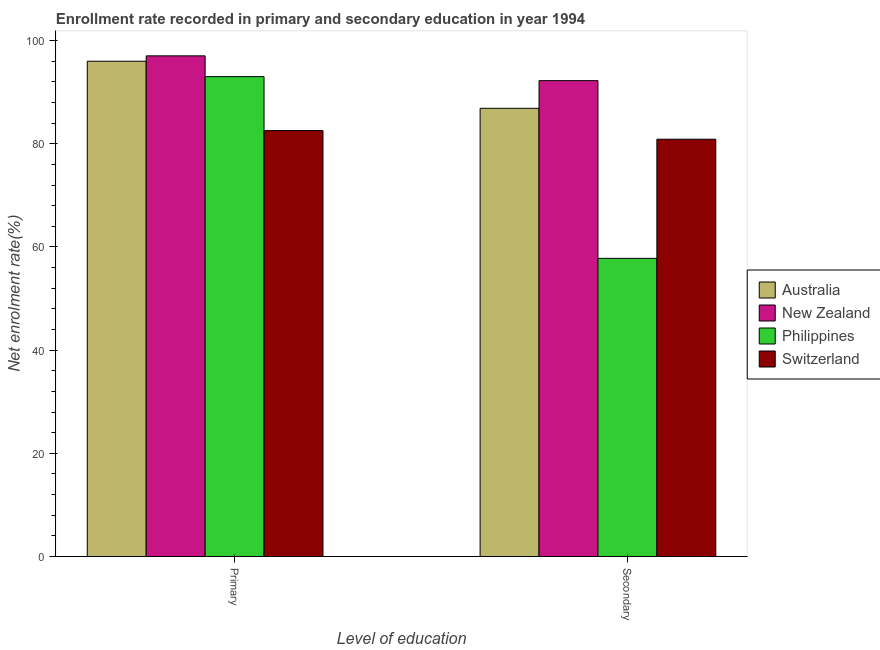How many groups of bars are there?
Provide a succinct answer. 2. Are the number of bars per tick equal to the number of legend labels?
Keep it short and to the point. Yes. Are the number of bars on each tick of the X-axis equal?
Your answer should be compact. Yes. How many bars are there on the 1st tick from the left?
Offer a terse response. 4. What is the label of the 2nd group of bars from the left?
Your answer should be compact. Secondary. What is the enrollment rate in primary education in Switzerland?
Your answer should be compact. 82.55. Across all countries, what is the maximum enrollment rate in secondary education?
Provide a succinct answer. 92.23. Across all countries, what is the minimum enrollment rate in secondary education?
Make the answer very short. 57.79. In which country was the enrollment rate in secondary education maximum?
Provide a short and direct response. New Zealand. In which country was the enrollment rate in secondary education minimum?
Your answer should be compact. Philippines. What is the total enrollment rate in secondary education in the graph?
Offer a terse response. 317.78. What is the difference between the enrollment rate in secondary education in Australia and that in New Zealand?
Provide a succinct answer. -5.36. What is the difference between the enrollment rate in primary education in New Zealand and the enrollment rate in secondary education in Switzerland?
Offer a terse response. 16.15. What is the average enrollment rate in primary education per country?
Provide a succinct answer. 92.15. What is the difference between the enrollment rate in secondary education and enrollment rate in primary education in Switzerland?
Make the answer very short. -1.67. In how many countries, is the enrollment rate in primary education greater than 4 %?
Make the answer very short. 4. What is the ratio of the enrollment rate in primary education in New Zealand to that in Australia?
Offer a very short reply. 1.01. Is the enrollment rate in secondary education in Philippines less than that in Switzerland?
Keep it short and to the point. Yes. In how many countries, is the enrollment rate in primary education greater than the average enrollment rate in primary education taken over all countries?
Ensure brevity in your answer.  3. What does the 2nd bar from the left in Primary represents?
Provide a short and direct response. New Zealand. What does the 3rd bar from the right in Secondary represents?
Your answer should be very brief. New Zealand. Are all the bars in the graph horizontal?
Ensure brevity in your answer.  No. What is the difference between two consecutive major ticks on the Y-axis?
Offer a terse response. 20. Does the graph contain any zero values?
Provide a short and direct response. No. Where does the legend appear in the graph?
Offer a terse response. Center right. How many legend labels are there?
Provide a succinct answer. 4. How are the legend labels stacked?
Give a very brief answer. Vertical. What is the title of the graph?
Provide a short and direct response. Enrollment rate recorded in primary and secondary education in year 1994. Does "Philippines" appear as one of the legend labels in the graph?
Your answer should be very brief. Yes. What is the label or title of the X-axis?
Provide a succinct answer. Level of education. What is the label or title of the Y-axis?
Keep it short and to the point. Net enrolment rate(%). What is the Net enrolment rate(%) of Australia in Primary?
Keep it short and to the point. 96. What is the Net enrolment rate(%) of New Zealand in Primary?
Offer a terse response. 97.04. What is the Net enrolment rate(%) of Philippines in Primary?
Provide a short and direct response. 93.01. What is the Net enrolment rate(%) in Switzerland in Primary?
Your answer should be compact. 82.55. What is the Net enrolment rate(%) in Australia in Secondary?
Make the answer very short. 86.87. What is the Net enrolment rate(%) in New Zealand in Secondary?
Your answer should be very brief. 92.23. What is the Net enrolment rate(%) in Philippines in Secondary?
Ensure brevity in your answer.  57.79. What is the Net enrolment rate(%) in Switzerland in Secondary?
Keep it short and to the point. 80.88. Across all Level of education, what is the maximum Net enrolment rate(%) of Australia?
Give a very brief answer. 96. Across all Level of education, what is the maximum Net enrolment rate(%) of New Zealand?
Your answer should be compact. 97.04. Across all Level of education, what is the maximum Net enrolment rate(%) of Philippines?
Your answer should be very brief. 93.01. Across all Level of education, what is the maximum Net enrolment rate(%) of Switzerland?
Offer a terse response. 82.55. Across all Level of education, what is the minimum Net enrolment rate(%) in Australia?
Provide a succinct answer. 86.87. Across all Level of education, what is the minimum Net enrolment rate(%) of New Zealand?
Offer a very short reply. 92.23. Across all Level of education, what is the minimum Net enrolment rate(%) of Philippines?
Keep it short and to the point. 57.79. Across all Level of education, what is the minimum Net enrolment rate(%) in Switzerland?
Keep it short and to the point. 80.88. What is the total Net enrolment rate(%) of Australia in the graph?
Keep it short and to the point. 182.87. What is the total Net enrolment rate(%) in New Zealand in the graph?
Provide a succinct answer. 189.27. What is the total Net enrolment rate(%) in Philippines in the graph?
Your answer should be compact. 150.8. What is the total Net enrolment rate(%) in Switzerland in the graph?
Give a very brief answer. 163.43. What is the difference between the Net enrolment rate(%) of Australia in Primary and that in Secondary?
Your answer should be compact. 9.12. What is the difference between the Net enrolment rate(%) in New Zealand in Primary and that in Secondary?
Your response must be concise. 4.8. What is the difference between the Net enrolment rate(%) of Philippines in Primary and that in Secondary?
Keep it short and to the point. 35.22. What is the difference between the Net enrolment rate(%) of Switzerland in Primary and that in Secondary?
Your answer should be very brief. 1.67. What is the difference between the Net enrolment rate(%) of Australia in Primary and the Net enrolment rate(%) of New Zealand in Secondary?
Provide a succinct answer. 3.77. What is the difference between the Net enrolment rate(%) in Australia in Primary and the Net enrolment rate(%) in Philippines in Secondary?
Your response must be concise. 38.21. What is the difference between the Net enrolment rate(%) in Australia in Primary and the Net enrolment rate(%) in Switzerland in Secondary?
Provide a succinct answer. 15.11. What is the difference between the Net enrolment rate(%) of New Zealand in Primary and the Net enrolment rate(%) of Philippines in Secondary?
Your answer should be compact. 39.25. What is the difference between the Net enrolment rate(%) of New Zealand in Primary and the Net enrolment rate(%) of Switzerland in Secondary?
Provide a short and direct response. 16.15. What is the difference between the Net enrolment rate(%) of Philippines in Primary and the Net enrolment rate(%) of Switzerland in Secondary?
Ensure brevity in your answer.  12.13. What is the average Net enrolment rate(%) of Australia per Level of education?
Offer a terse response. 91.43. What is the average Net enrolment rate(%) of New Zealand per Level of education?
Offer a terse response. 94.63. What is the average Net enrolment rate(%) of Philippines per Level of education?
Provide a short and direct response. 75.4. What is the average Net enrolment rate(%) of Switzerland per Level of education?
Offer a very short reply. 81.72. What is the difference between the Net enrolment rate(%) of Australia and Net enrolment rate(%) of New Zealand in Primary?
Your answer should be very brief. -1.04. What is the difference between the Net enrolment rate(%) in Australia and Net enrolment rate(%) in Philippines in Primary?
Offer a terse response. 2.99. What is the difference between the Net enrolment rate(%) of Australia and Net enrolment rate(%) of Switzerland in Primary?
Your response must be concise. 13.44. What is the difference between the Net enrolment rate(%) in New Zealand and Net enrolment rate(%) in Philippines in Primary?
Offer a terse response. 4.03. What is the difference between the Net enrolment rate(%) of New Zealand and Net enrolment rate(%) of Switzerland in Primary?
Provide a short and direct response. 14.48. What is the difference between the Net enrolment rate(%) in Philippines and Net enrolment rate(%) in Switzerland in Primary?
Give a very brief answer. 10.45. What is the difference between the Net enrolment rate(%) of Australia and Net enrolment rate(%) of New Zealand in Secondary?
Keep it short and to the point. -5.36. What is the difference between the Net enrolment rate(%) of Australia and Net enrolment rate(%) of Philippines in Secondary?
Keep it short and to the point. 29.08. What is the difference between the Net enrolment rate(%) of Australia and Net enrolment rate(%) of Switzerland in Secondary?
Your answer should be compact. 5.99. What is the difference between the Net enrolment rate(%) of New Zealand and Net enrolment rate(%) of Philippines in Secondary?
Offer a very short reply. 34.44. What is the difference between the Net enrolment rate(%) in New Zealand and Net enrolment rate(%) in Switzerland in Secondary?
Provide a succinct answer. 11.35. What is the difference between the Net enrolment rate(%) of Philippines and Net enrolment rate(%) of Switzerland in Secondary?
Make the answer very short. -23.09. What is the ratio of the Net enrolment rate(%) in Australia in Primary to that in Secondary?
Ensure brevity in your answer.  1.1. What is the ratio of the Net enrolment rate(%) in New Zealand in Primary to that in Secondary?
Offer a terse response. 1.05. What is the ratio of the Net enrolment rate(%) of Philippines in Primary to that in Secondary?
Ensure brevity in your answer.  1.61. What is the ratio of the Net enrolment rate(%) of Switzerland in Primary to that in Secondary?
Your answer should be very brief. 1.02. What is the difference between the highest and the second highest Net enrolment rate(%) in Australia?
Give a very brief answer. 9.12. What is the difference between the highest and the second highest Net enrolment rate(%) in New Zealand?
Ensure brevity in your answer.  4.8. What is the difference between the highest and the second highest Net enrolment rate(%) in Philippines?
Your answer should be very brief. 35.22. What is the difference between the highest and the second highest Net enrolment rate(%) of Switzerland?
Your response must be concise. 1.67. What is the difference between the highest and the lowest Net enrolment rate(%) of Australia?
Keep it short and to the point. 9.12. What is the difference between the highest and the lowest Net enrolment rate(%) in New Zealand?
Keep it short and to the point. 4.8. What is the difference between the highest and the lowest Net enrolment rate(%) of Philippines?
Your answer should be compact. 35.22. What is the difference between the highest and the lowest Net enrolment rate(%) in Switzerland?
Give a very brief answer. 1.67. 